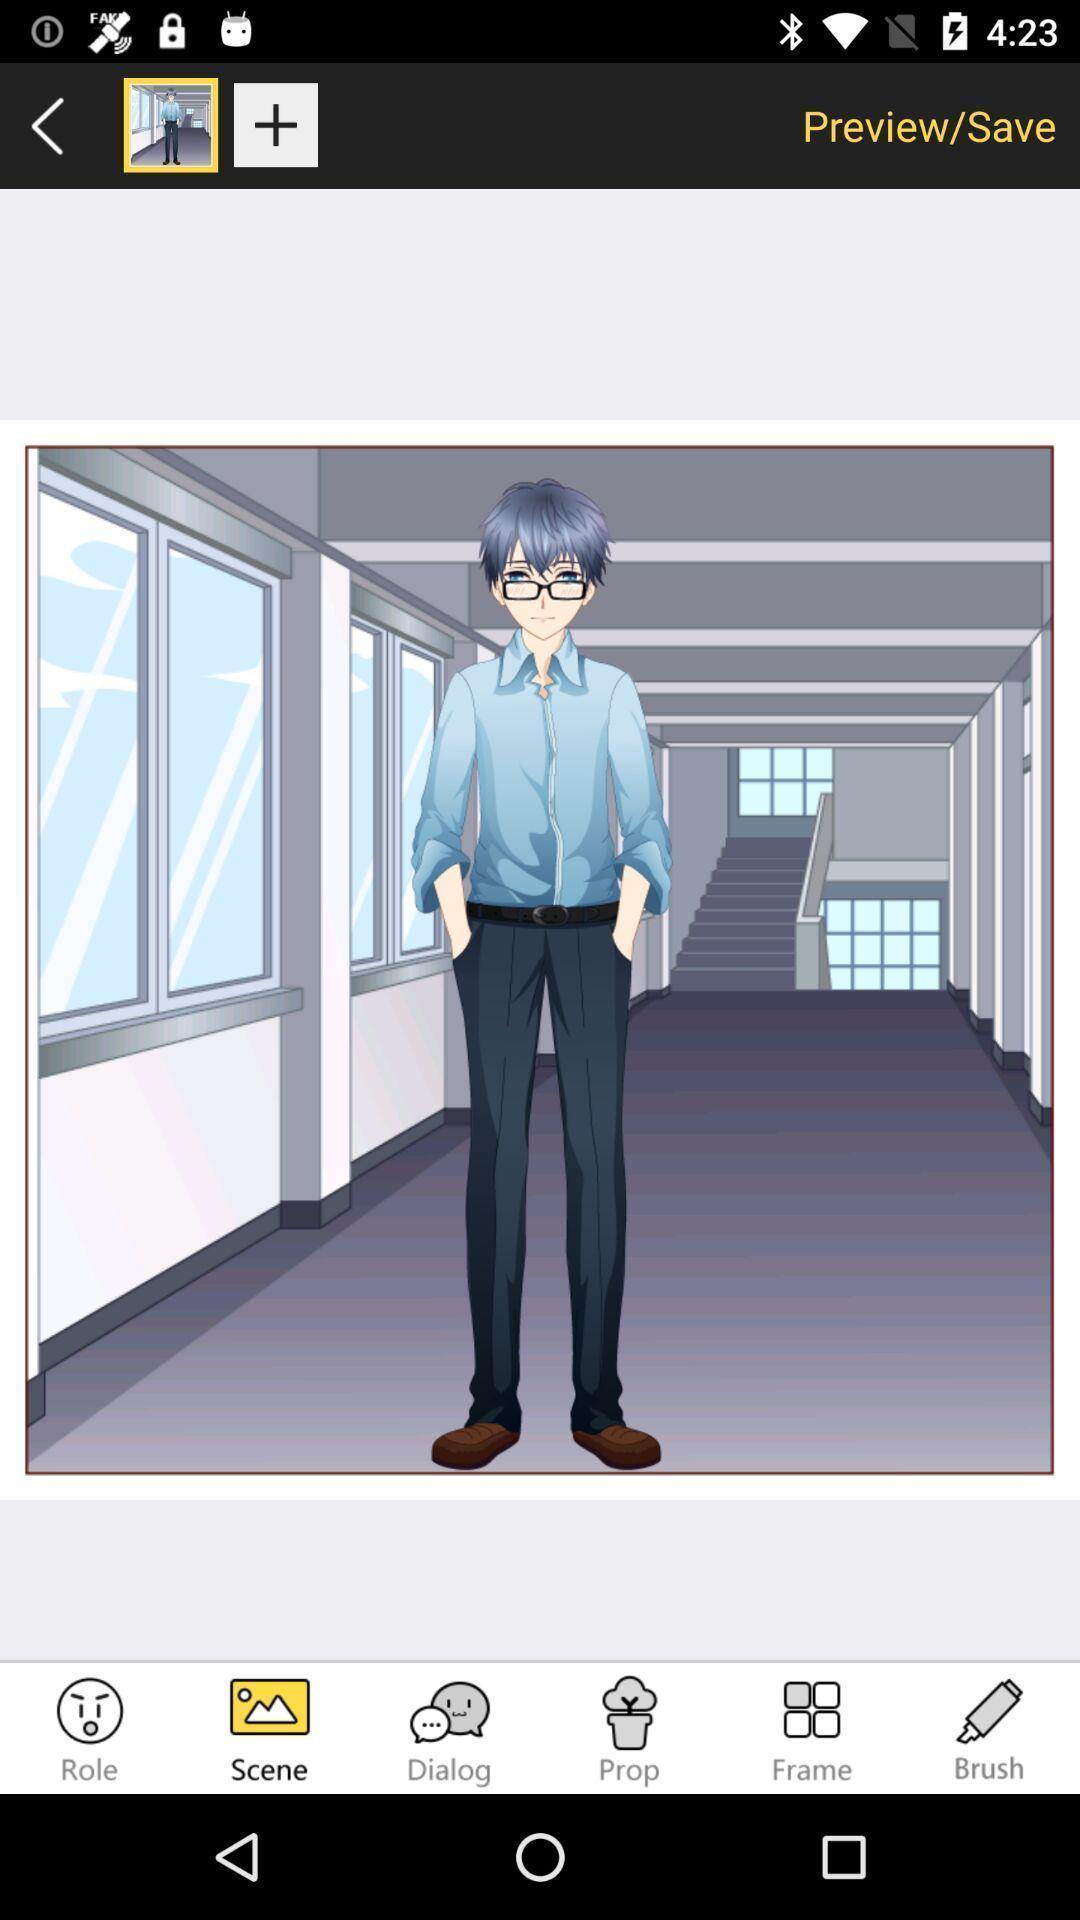Explain what's happening in this screen capture. Screen displaying about cartoon image. 